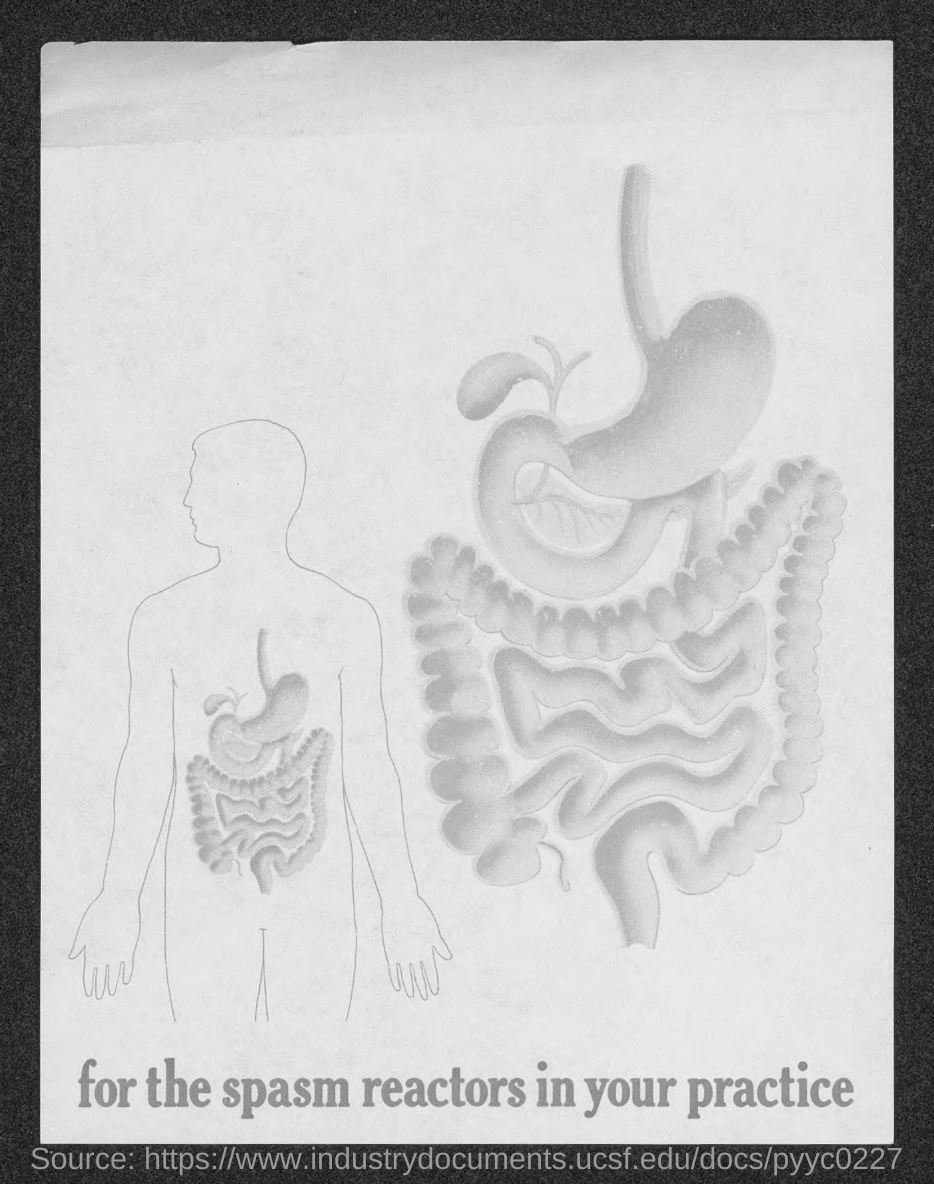Highlight a few significant elements in this photo. The text provided in this document pertains to the use of spasm reactors in practice. 